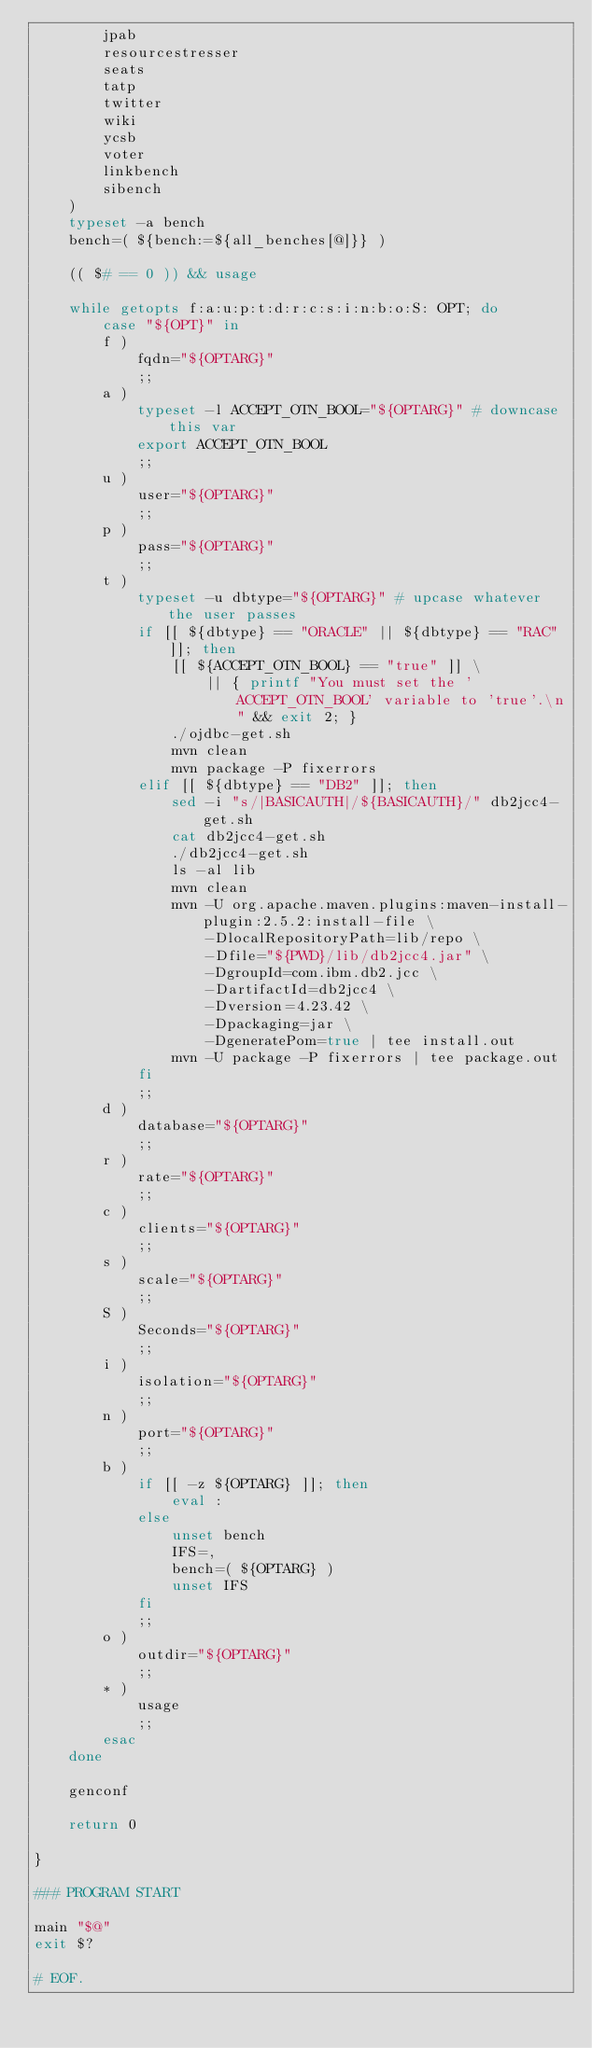Convert code to text. <code><loc_0><loc_0><loc_500><loc_500><_Bash_>        jpab
        resourcestresser
        seats
        tatp
        twitter
        wiki
        ycsb
        voter
        linkbench
        sibench
    )
    typeset -a bench
    bench=( ${bench:=${all_benches[@]}} )

    (( $# == 0 )) && usage

    while getopts f:a:u:p:t:d:r:c:s:i:n:b:o:S: OPT; do
        case "${OPT}" in
        f )
            fqdn="${OPTARG}"
            ;;
        a )
            typeset -l ACCEPT_OTN_BOOL="${OPTARG}" # downcase this var
            export ACCEPT_OTN_BOOL
            ;;
        u )
            user="${OPTARG}"
            ;;
        p )
            pass="${OPTARG}"
            ;;
        t )
            typeset -u dbtype="${OPTARG}" # upcase whatever the user passes
            if [[ ${dbtype} == "ORACLE" || ${dbtype} == "RAC" ]]; then
                [[ ${ACCEPT_OTN_BOOL} == "true" ]] \
                    || { printf "You must set the 'ACCEPT_OTN_BOOL' variable to 'true'.\n" && exit 2; }
                ./ojdbc-get.sh
                mvn clean
                mvn package -P fixerrors
            elif [[ ${dbtype} == "DB2" ]]; then
                sed -i "s/|BASICAUTH|/${BASICAUTH}/" db2jcc4-get.sh
                cat db2jcc4-get.sh
                ./db2jcc4-get.sh
                ls -al lib
                mvn clean
                mvn -U org.apache.maven.plugins:maven-install-plugin:2.5.2:install-file \
                    -DlocalRepositoryPath=lib/repo \
                    -Dfile="${PWD}/lib/db2jcc4.jar" \
                    -DgroupId=com.ibm.db2.jcc \
                    -DartifactId=db2jcc4 \
                    -Dversion=4.23.42 \
                    -Dpackaging=jar \
                    -DgeneratePom=true | tee install.out
                mvn -U package -P fixerrors | tee package.out
            fi
            ;;
        d )
            database="${OPTARG}"
            ;;
        r )
            rate="${OPTARG}"
            ;;
        c )
            clients="${OPTARG}"
            ;;
        s )
            scale="${OPTARG}"
            ;;
        S )
            Seconds="${OPTARG}"
            ;;
        i )
            isolation="${OPTARG}"
            ;;
        n )
            port="${OPTARG}"
            ;;
        b )
            if [[ -z ${OPTARG} ]]; then
                eval :
            else
                unset bench
                IFS=,
                bench=( ${OPTARG} )
                unset IFS
            fi
            ;;
        o )
            outdir="${OPTARG}"
            ;;
        * )
            usage
            ;;
        esac
    done

    genconf

    return 0

}

### PROGRAM START

main "$@"
exit $?

# EOF.
</code> 